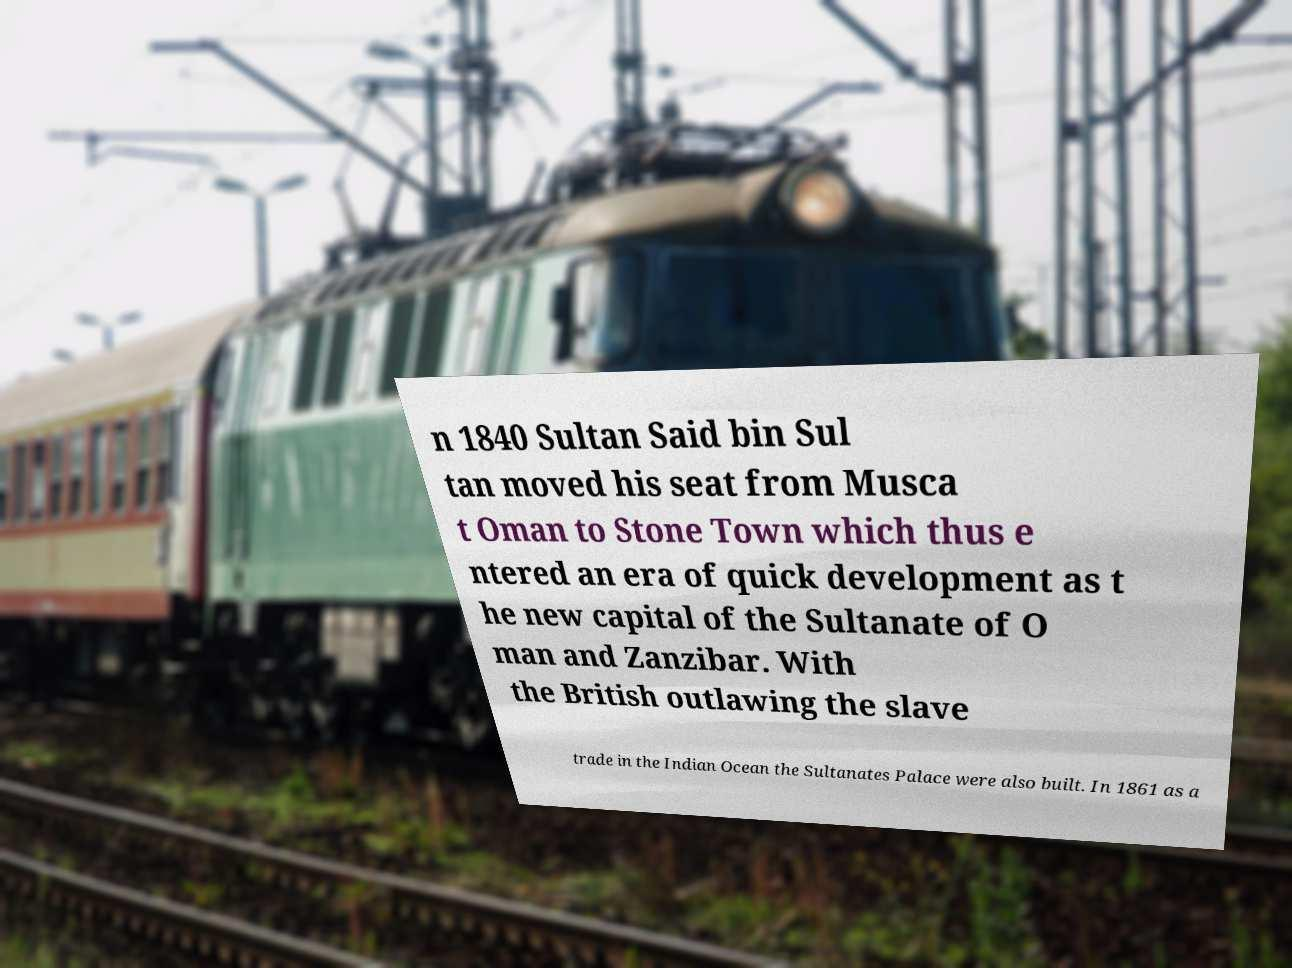Please identify and transcribe the text found in this image. n 1840 Sultan Said bin Sul tan moved his seat from Musca t Oman to Stone Town which thus e ntered an era of quick development as t he new capital of the Sultanate of O man and Zanzibar. With the British outlawing the slave trade in the Indian Ocean the Sultanates Palace were also built. In 1861 as a 